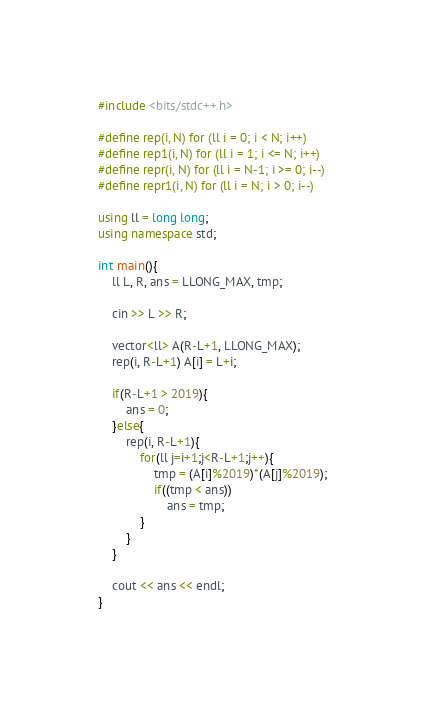Convert code to text. <code><loc_0><loc_0><loc_500><loc_500><_C++_>#include <bits/stdc++.h>

#define rep(i, N) for (ll i = 0; i < N; i++)
#define rep1(i, N) for (ll i = 1; i <= N; i++)
#define repr(i, N) for (ll i = N-1; i >= 0; i--)
#define repr1(i, N) for (ll i = N; i > 0; i--)

using ll = long long;
using namespace std;

int main(){
    ll L, R, ans = LLONG_MAX, tmp;

    cin >> L >> R;
    
    vector<ll> A(R-L+1, LLONG_MAX);
    rep(i, R-L+1) A[i] = L+i;

    if(R-L+1 > 2019){
        ans = 0;
    }else{
        rep(i, R-L+1){
            for(ll j=i+1;j<R-L+1;j++){
                tmp = (A[i]%2019)*(A[j]%2019);
                if((tmp < ans))
                    ans = tmp;
            }
        }
    }

    cout << ans << endl;
}
</code> 